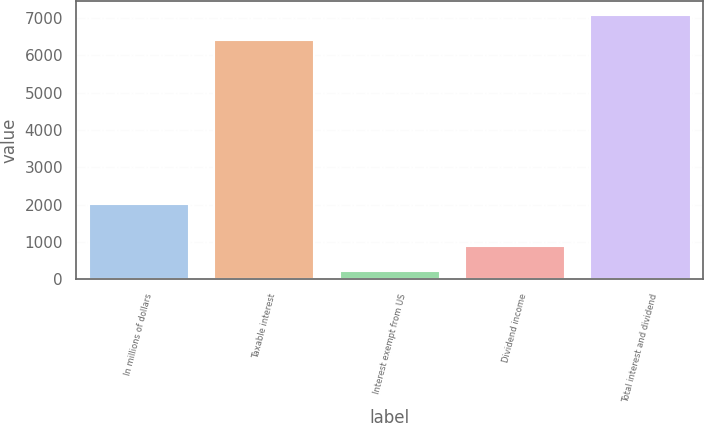Convert chart to OTSL. <chart><loc_0><loc_0><loc_500><loc_500><bar_chart><fcel>In millions of dollars<fcel>Taxable interest<fcel>Interest exempt from US<fcel>Dividend income<fcel>Total interest and dividend<nl><fcel>2015<fcel>6414<fcel>215<fcel>895.2<fcel>7094.2<nl></chart> 